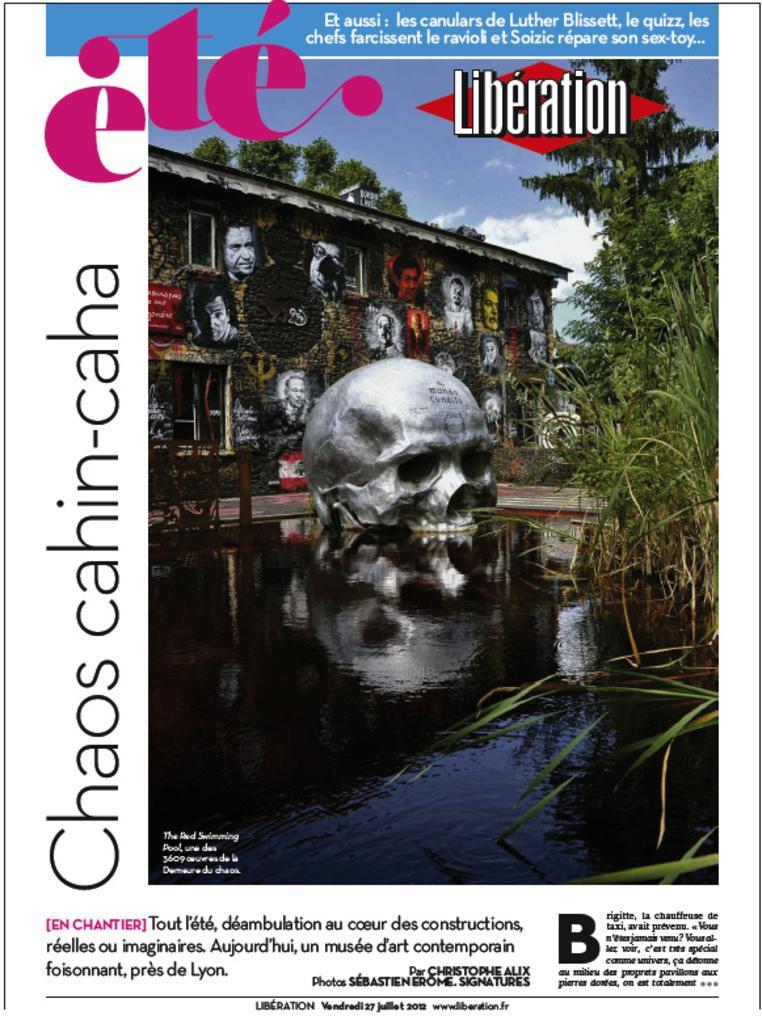How would you summarize this image in a sentence or two? In this image I can see the water. On the right side, I can see the trees. At the top I can see the clouds in the sky. 